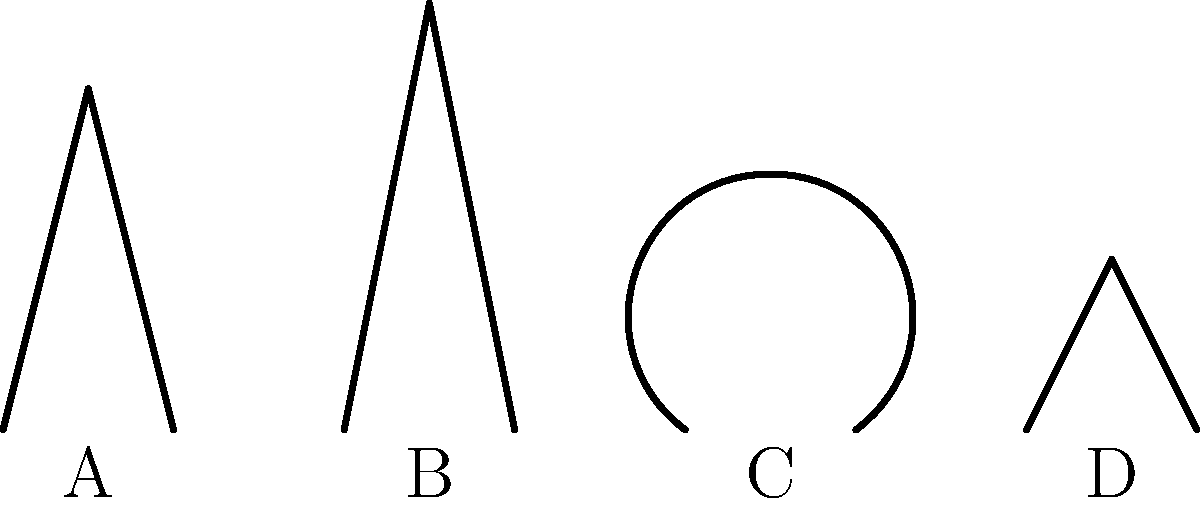As a vampire aficionado with a keen eye for detail and a good sense of humor, you've been tasked with identifying the most menacing vampire fang shape. Based on the diagram above, which fang type would you say belongs to the infamous "Count Chuckula," known for his deadly bite and killer jokes? Let's analyze each fang type with a bit of vampire humor:

1. Fang A: This fang has a moderate length and a sharp point. It's a classic vampire look, but not particularly menacing. We'll call this the "Twilight Tickler."

2. Fang B: This is the longest and most pointed fang. It's definitely the most threatening and would deliver the deepest bite. This is our prime candidate for Count Chuckula's chompers.

3. Fang C: This fang has a curved shape, almost like a smile. While it might be good for a vampire with a friendly demeanor, it's not the most effective for biting. We'll dub this the "Friendly Fang."

4. Fang D: This is the shortest fang with a quick point. It might be good for quick nips, but not for a legendary bite. Let's call this the "Rookie Ripper."

Given Count Chuckula's reputation for a deadly bite and killer jokes, we need a fang that's both menacing and somewhat comical. Fang B fits this description perfectly. Its exaggerated length and sharp point make it the most threatening, while its slightly over-the-top appearance adds a touch of humor.

Therefore, the fang that best suits Count Chuckula's persona is Fang B.
Answer: Fang B 